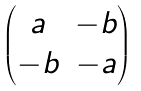<formula> <loc_0><loc_0><loc_500><loc_500>\begin{pmatrix} a & - b \\ - b & - a \end{pmatrix}</formula> 